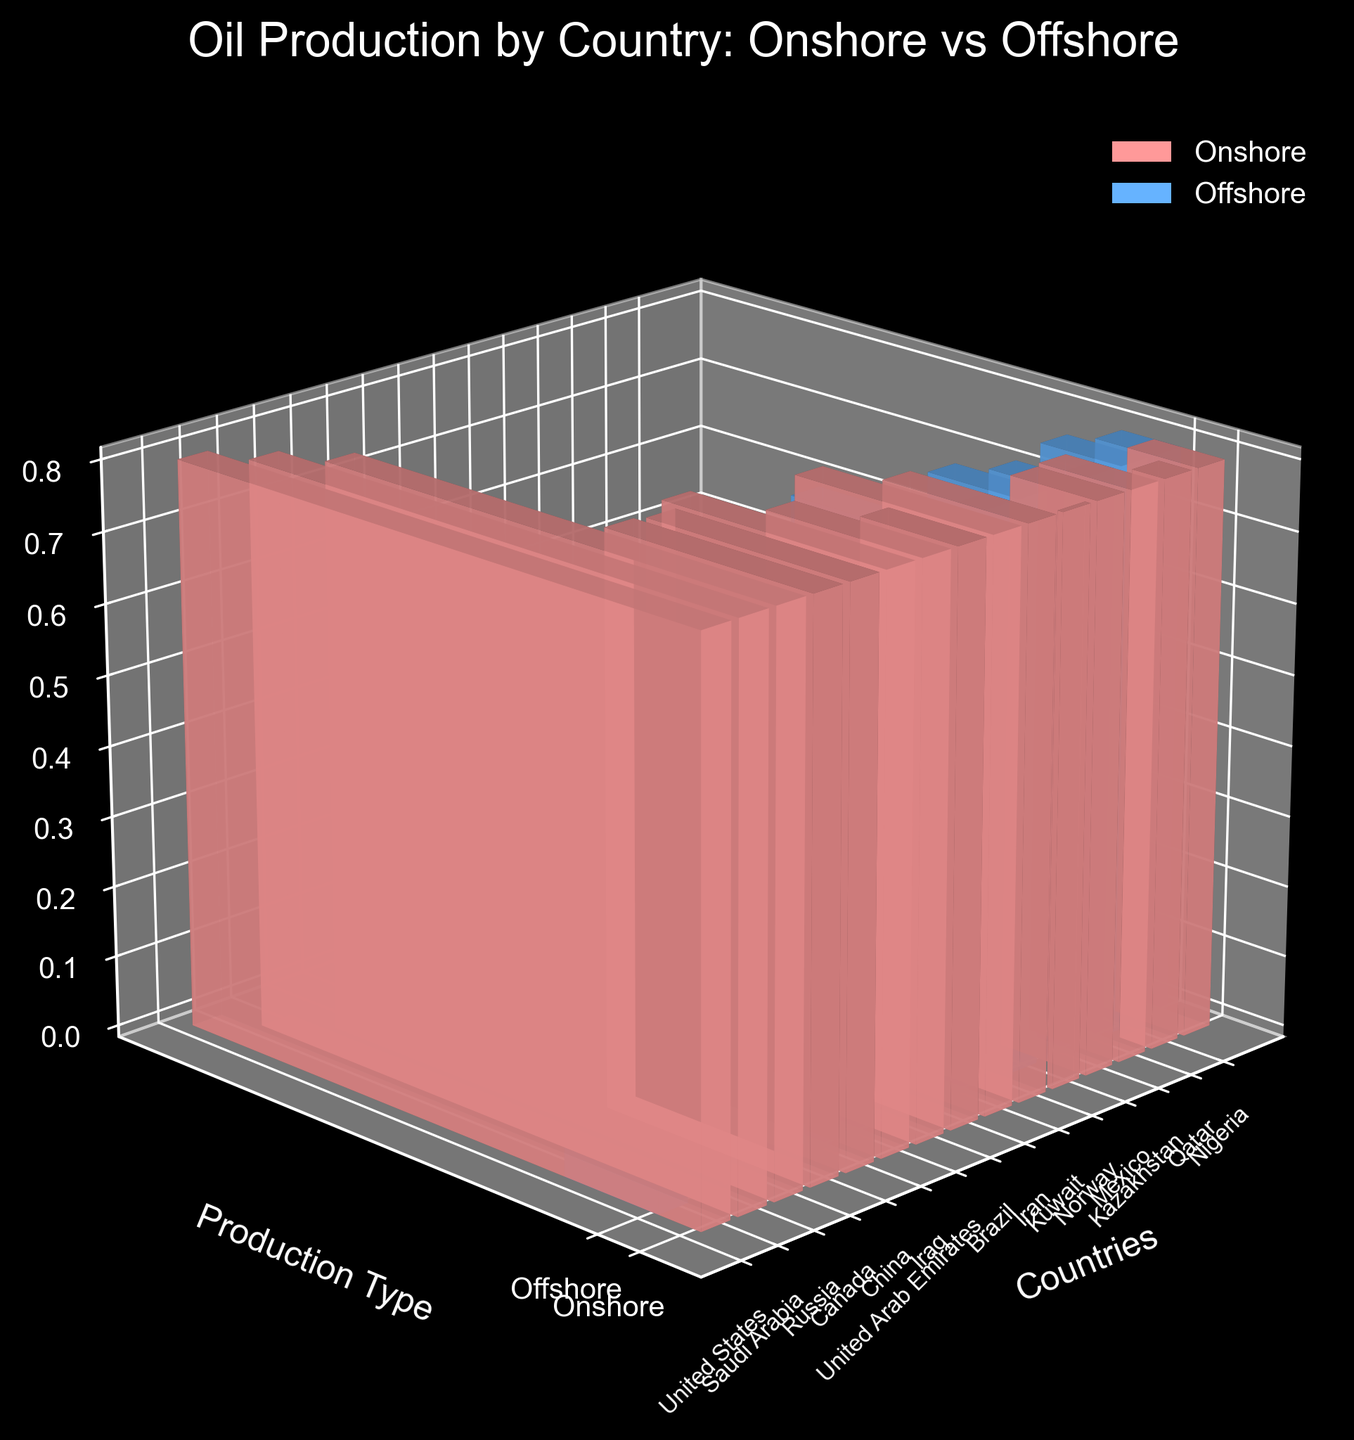What's the title of the figure? The title of the figure is located at the top and reads "Oil Production by Country: Onshore vs Offshore".
Answer: Oil Production by Country: Onshore vs Offshore What are the labels for the x, y, and z axes? The labels for the axes are located next to each axis. The x-axis is labeled "Countries", the y-axis is labeled "Production Type", and the z-axis is labeled "Oil Production (million barrels/day)".
Answer: Countries, Production Type, Oil Production (million barrels/day) Which country has the highest onshore oil production? To determine the country with the highest onshore oil production, find the tallest bar in the "Onshore" category. The United States has the tallest onshore bar at approximately 10.2 million barrels/day.
Answer: United States Which country has the highest offshore oil production? To find the country with the highest offshore oil production, locate the tallest bar in the "Offshore" section. Brazil has the highest offshore production at approximately 2.3 million barrels/day.
Answer: Brazil What are the two countries with the lowest combined onshore and offshore production? To find the two countries with the lowest combined production, sum the onshore and offshore values for each country and identify the smallest sums. Norway (0.1 onshore + 1.7 offshore = 1.8) and Qatar (0.6 onshore + 1.5 offshore = 2.1) have the lowest combined production.
Answer: Norway, Qatar What's the total offshore production for all countries combined? To find the total offshore production, sum the offshore values for all countries: 1.8 + 2.1 + 1.3 + 0.3 + 0.5 + 0.1 + 1.6 + 2.3 + 0.2 + 0.5 + 1.7 + 1.2 + 0.4 + 1.5 + 1.1 = 16.6 million barrels/day.
Answer: 16.6 million barrels/day What is the average onshore production for the countries listed? To find the average onshore production, sum the onshore values and divide by the number of countries: (10.2 + 9.5 + 8.7 + 3.9 + 3.8 + 4.2 + 2.9 + 1.8 + 3.7 + 2.7 + 0.1 + 1.6 + 1.7 + 0.6 + 1.3) / 15 = 3.88 million barrels/day.
Answer: 3.88 million barrels/day Which country has a higher offshore production than onshore production? By comparing the onshore and offshore bars for each country, Brazil is the only country where the offshore production (2.3 million barrels/day) is higher than onshore production (1.8 million barrels/day).
Answer: Brazil 